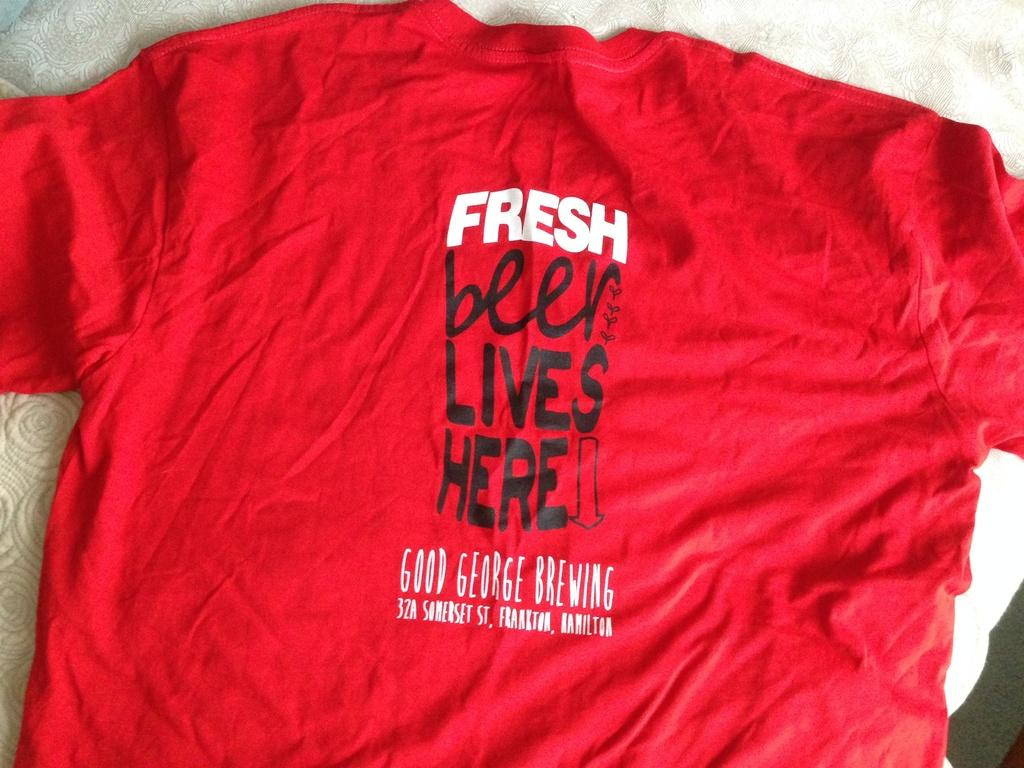<image>
Offer a succinct explanation of the picture presented. T-shirt laying on a towel that says "FRESH beer LIVES HERE" with an arrow pointing to the wearer's belly. 